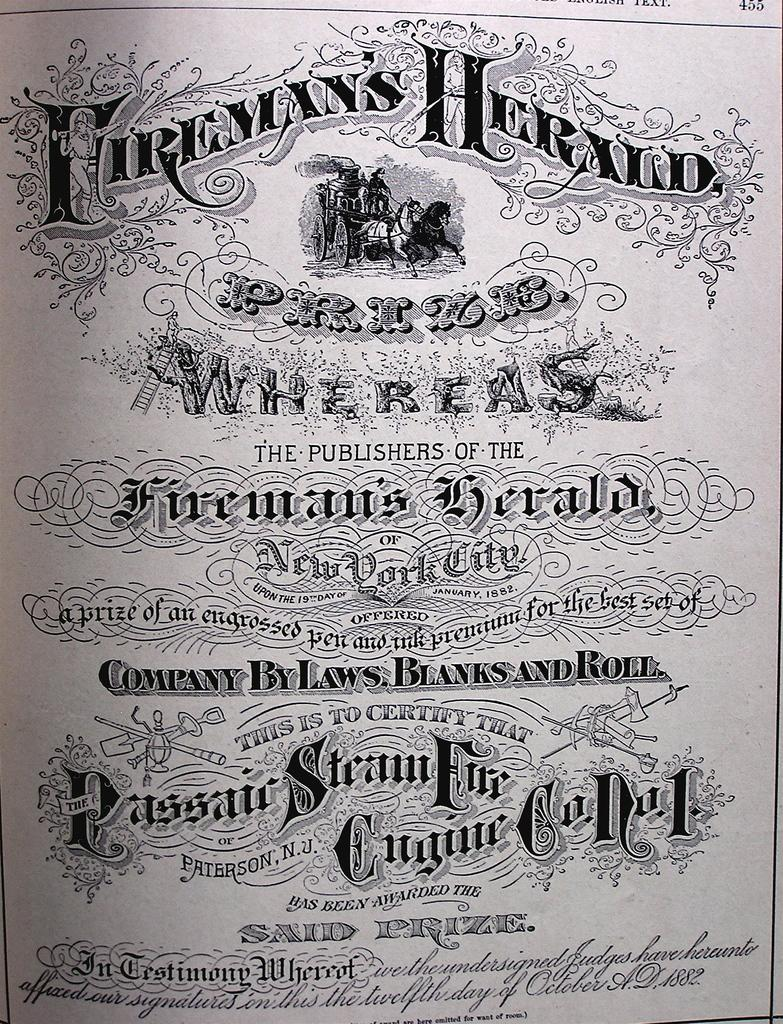<image>
Offer a succinct explanation of the picture presented. Fireman's Herald prize sign that is company by laws, blanks, and roll 